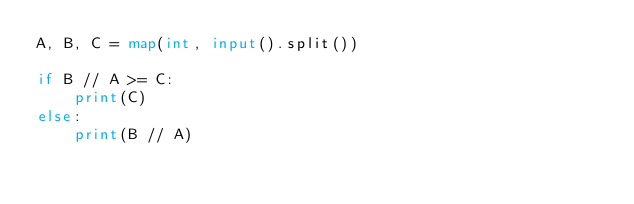<code> <loc_0><loc_0><loc_500><loc_500><_Python_>A, B, C = map(int, input().split())

if B // A >= C:
	print(C)
else:
	print(B // A)</code> 